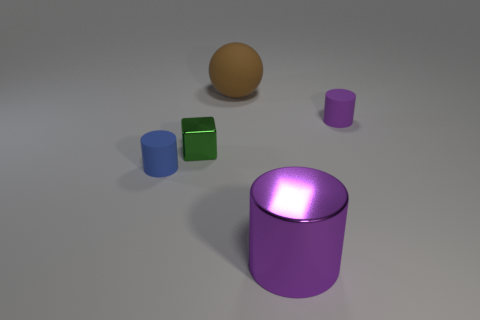Add 3 purple cylinders. How many objects exist? 8 Subtract all cylinders. How many objects are left? 2 Add 1 big purple cylinders. How many big purple cylinders are left? 2 Add 1 big metal objects. How many big metal objects exist? 2 Subtract 0 cyan blocks. How many objects are left? 5 Subtract all big shiny objects. Subtract all balls. How many objects are left? 3 